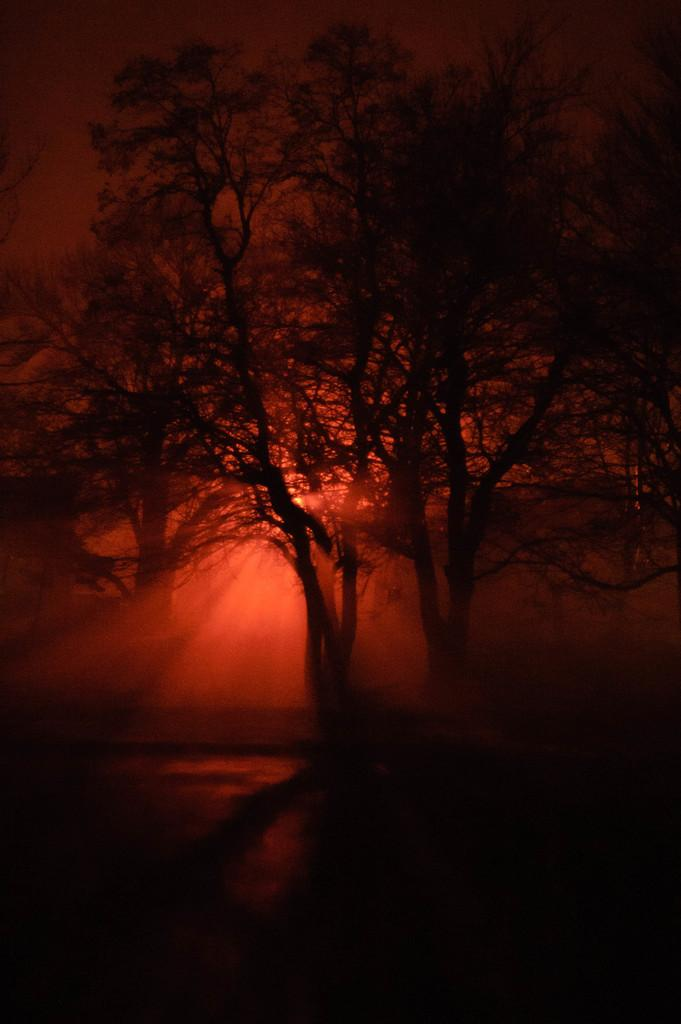What type of vegetation can be seen in the image? There are trees in the image. What can be observed about the sunlight in the image? Sun rays are visible in the image. What type of fact can be seen in the image? There is no specific fact visible in the image; it primarily features trees and sun rays. 